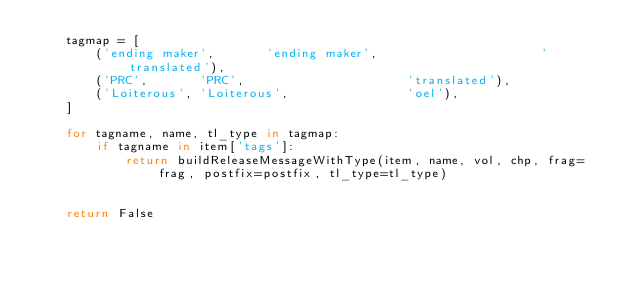Convert code to text. <code><loc_0><loc_0><loc_500><loc_500><_Python_>	tagmap = [
		('ending maker',       'ending maker',                      'translated'),
		('PRC',       'PRC',                      'translated'),
		('Loiterous', 'Loiterous',                'oel'),
	]

	for tagname, name, tl_type in tagmap:
		if tagname in item['tags']:
			return buildReleaseMessageWithType(item, name, vol, chp, frag=frag, postfix=postfix, tl_type=tl_type)


	return False</code> 